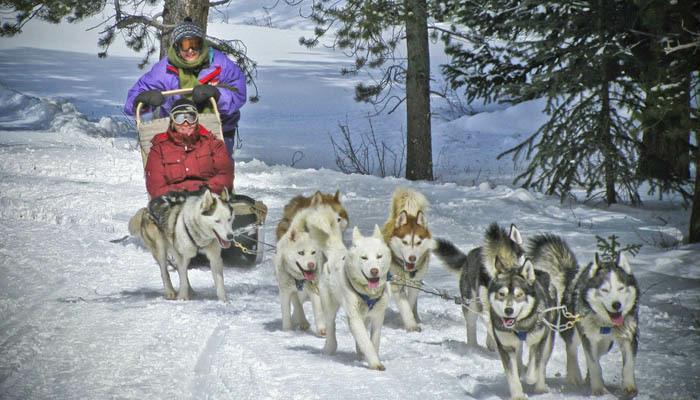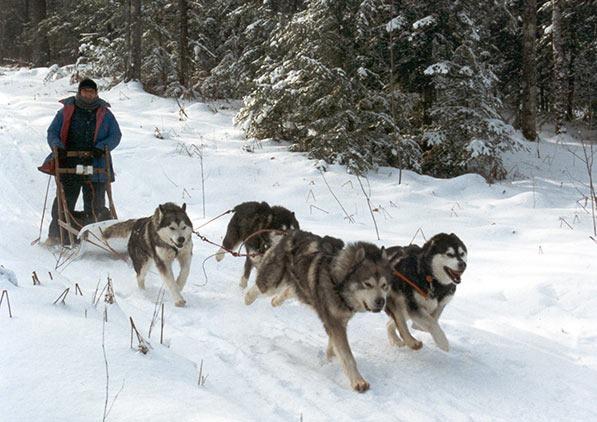The first image is the image on the left, the second image is the image on the right. Given the left and right images, does the statement "There is no human visible in one of the images." hold true? Answer yes or no. No. The first image is the image on the left, the second image is the image on the right. Analyze the images presented: Is the assertion "One image shows a dog sled team without a person." valid? Answer yes or no. No. The first image is the image on the left, the second image is the image on the right. For the images displayed, is the sentence "There are teams of sled dogs pulling dog sleds with mushers on them through the snow." factually correct? Answer yes or no. Yes. The first image is the image on the left, the second image is the image on the right. For the images shown, is this caption "No lead sled dogs wear booties, and a sled driver is not visible in at least one image." true? Answer yes or no. No. 